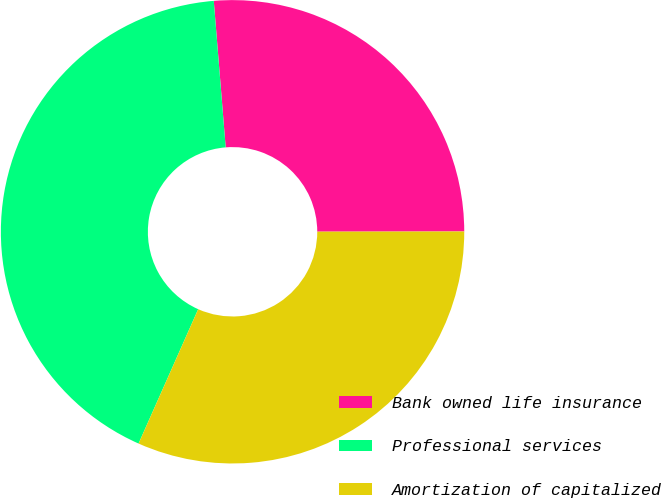Convert chart to OTSL. <chart><loc_0><loc_0><loc_500><loc_500><pie_chart><fcel>Bank owned life insurance<fcel>Professional services<fcel>Amortization of capitalized<nl><fcel>26.27%<fcel>42.06%<fcel>31.67%<nl></chart> 